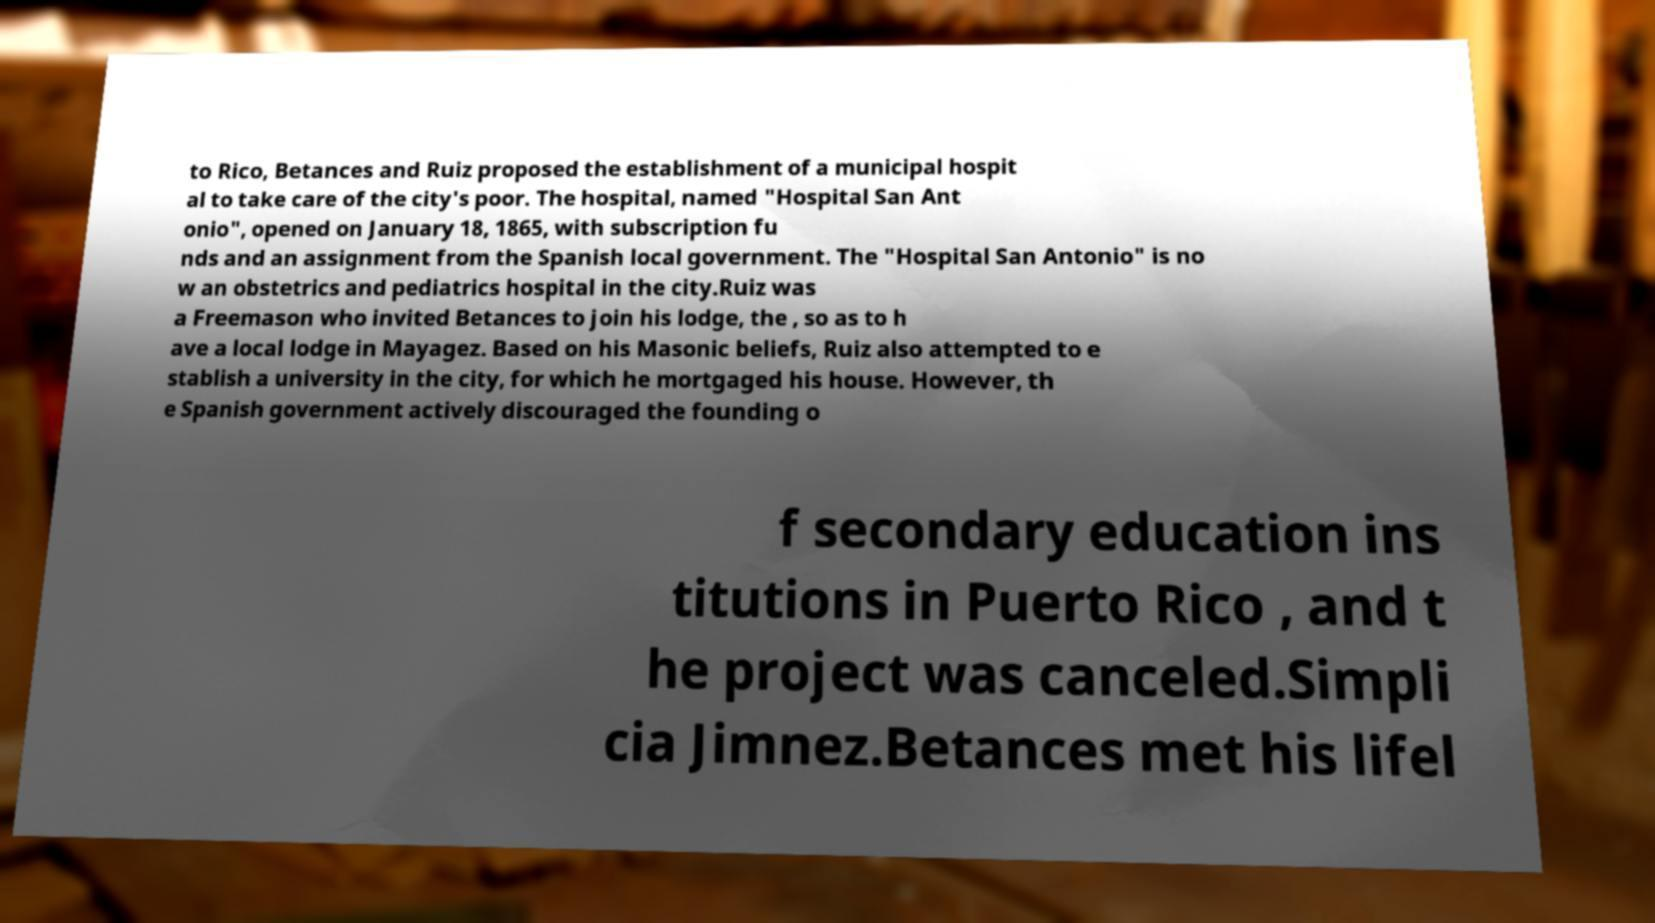Can you read and provide the text displayed in the image?This photo seems to have some interesting text. Can you extract and type it out for me? to Rico, Betances and Ruiz proposed the establishment of a municipal hospit al to take care of the city's poor. The hospital, named "Hospital San Ant onio", opened on January 18, 1865, with subscription fu nds and an assignment from the Spanish local government. The "Hospital San Antonio" is no w an obstetrics and pediatrics hospital in the city.Ruiz was a Freemason who invited Betances to join his lodge, the , so as to h ave a local lodge in Mayagez. Based on his Masonic beliefs, Ruiz also attempted to e stablish a university in the city, for which he mortgaged his house. However, th e Spanish government actively discouraged the founding o f secondary education ins titutions in Puerto Rico , and t he project was canceled.Simpli cia Jimnez.Betances met his lifel 